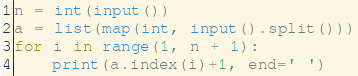<code> <loc_0><loc_0><loc_500><loc_500><_Python_>n = int(input())
a = list(map(int, input().split()))
for i in range(1, n + 1):
    print(a.index(i)+1, end=' ')</code> 